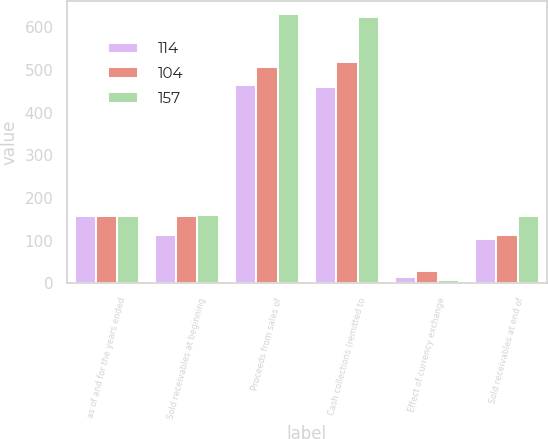<chart> <loc_0><loc_0><loc_500><loc_500><stacked_bar_chart><ecel><fcel>as of and for the years ended<fcel>Sold receivables at beginning<fcel>Proceeds from sales of<fcel>Cash collections (remitted to<fcel>Effect of currency exchange<fcel>Sold receivables at end of<nl><fcel>114<fcel>157<fcel>114<fcel>464<fcel>459<fcel>15<fcel>104<nl><fcel>104<fcel>157<fcel>157<fcel>506<fcel>519<fcel>30<fcel>114<nl><fcel>157<fcel>157<fcel>160<fcel>630<fcel>624<fcel>9<fcel>157<nl></chart> 